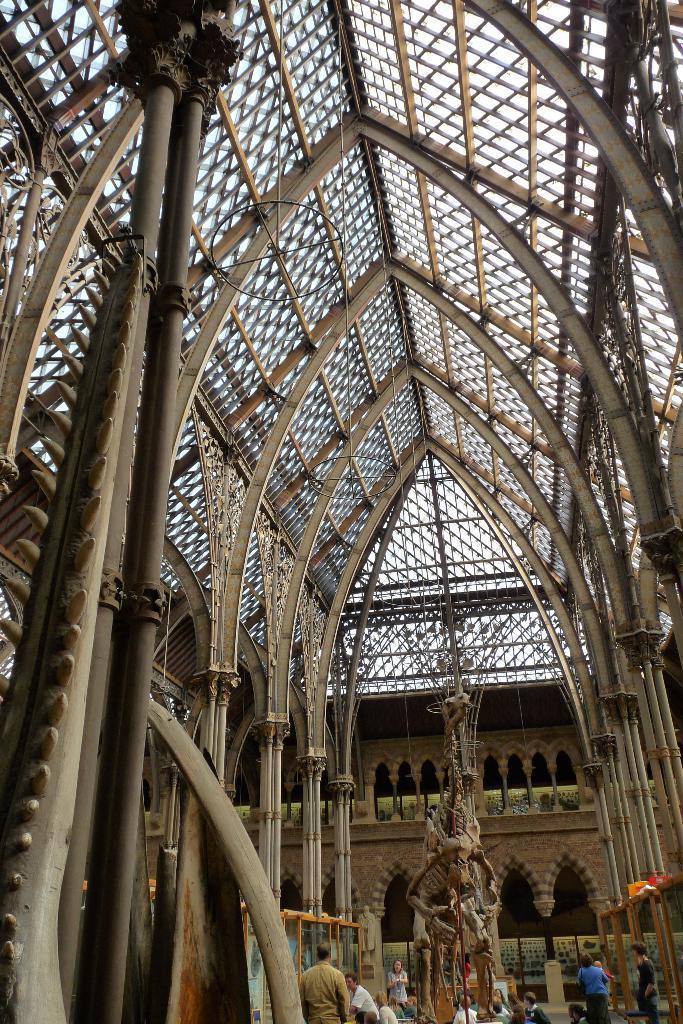In one or two sentences, can you explain what this image depicts? This is the picture of a building. In this image there is a skeleton of an animal and there are group of people. In the foreground there is a pole. At the top there is a roof and there is sky. 